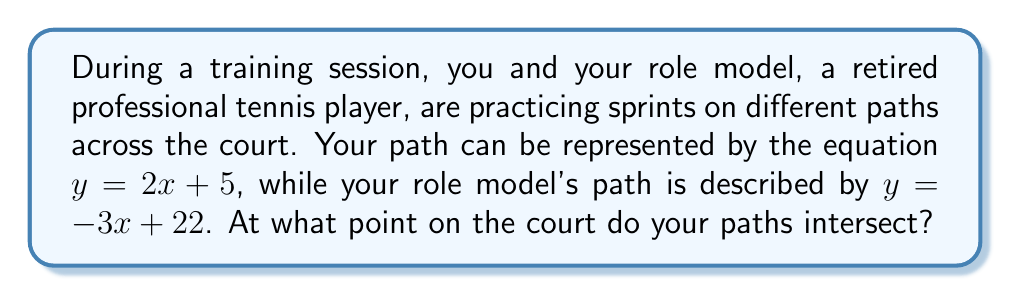Give your solution to this math problem. To find the intersection point of the two paths, we need to solve the system of equations:

$$\begin{cases}
y = 2x + 5 \\
y = -3x + 22
\end{cases}$$

Step 1: Set the equations equal to each other since they intersect at a point where y is the same for both equations.
$2x + 5 = -3x + 22$

Step 2: Solve for x by combining like terms and isolating x.
$2x + 3x = 22 - 5$
$5x = 17$
$x = \frac{17}{5} = 3.4$

Step 3: Substitute this x-value into either of the original equations to find y. Let's use your equation:
$y = 2(\frac{17}{5}) + 5$
$y = \frac{34}{5} + 5$
$y = \frac{34}{5} + \frac{25}{5} = \frac{59}{5} = 11.8$

Therefore, the paths intersect at the point $(\frac{17}{5}, \frac{59}{5})$ or $(3.4, 11.8)$ in decimal form.

[asy]
unitsize(20);
draw((-1,0)--(6,0),arrow=Arrow(TeXHead));
draw((0,-1)--(0,15),arrow=Arrow(TeXHead));
draw((0,5)--(5,15),blue);
draw((0,22)--(6,4),red);
dot((3.4,11.8));
label("(3.4, 11.8)",(3.4,11.8),NE);
label("x",(6,0),E);
label("y",(0,15),N);
label("Your path",(5,15),E,blue);
label("Role model's path",(6,4),SE,red);
[/asy]
Answer: $(\frac{17}{5}, \frac{59}{5})$ or $(3.4, 11.8)$ 